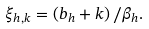<formula> <loc_0><loc_0><loc_500><loc_500>\xi _ { h , k } = \left ( b _ { h } + k \right ) / \beta _ { h } .</formula> 